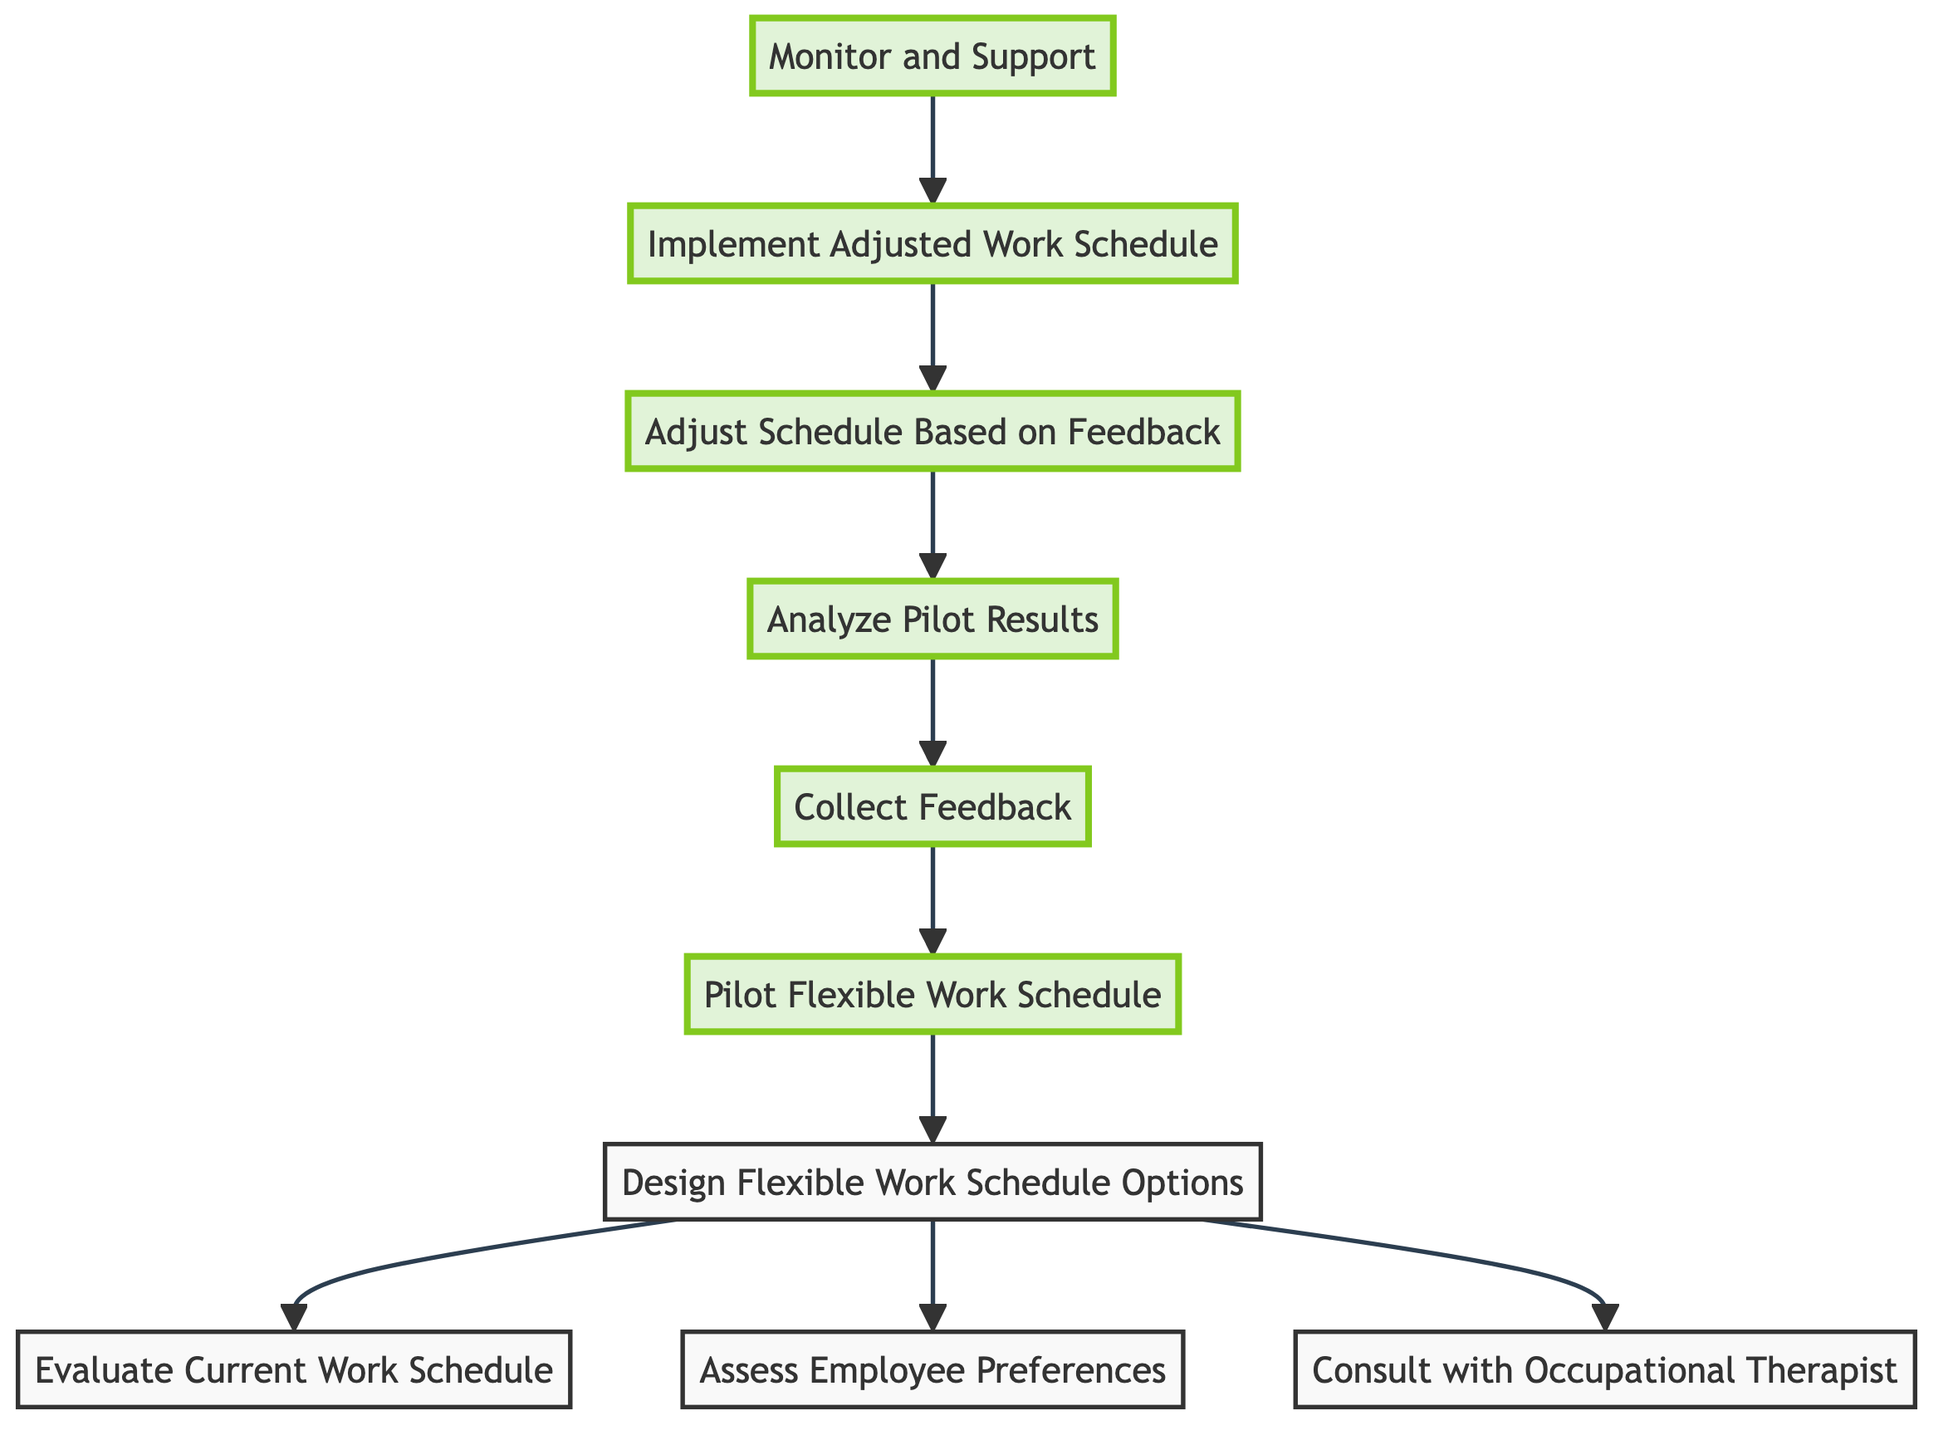What is the starting point of the process? The starting point is the first step in the flowchart, which is to evaluate the current work schedule.
Answer: Evaluate Current Work Schedule How many main steps are there in the process? By counting the distinct elements in the flowchart, there are a total of 10 main steps listed, including all nodes.
Answer: 10 What are the three requirements to design flexible work schedule options? To design options, the elements that need to be completed first are evaluating the current work schedule, assessing employee preferences, and consulting with an occupational therapist.
Answer: Evaluate Current Work Schedule, Assess Employee Preferences, Consult with Occupational Therapist Which step comes after collecting feedback? The step that follows collecting feedback is to analyze the pilot results, which evaluates the feedback and performance metrics.
Answer: Analyze Pilot Results What is the end goal of the flowchart process? The end goal of the process is to monitor and support the implemented adjusted work schedule's impact on employee satisfaction and productivity.
Answer: Monitor and Support Which elements are highlighted in the diagram? The elements that are highlighted in the diagram are the last five steps, which include implementing the adjusted work schedule, monitoring and supporting, adjusting the schedule based on feedback, analyzing pilot results, and collecting feedback.
Answer: Implement Adjusted Work Schedule, Monitor and Support, Adjust Schedule Based on Feedback, Analyze Pilot Results, Collect Feedback What is the direct action before implementing the adjusted work schedule? The direct action that must be taken before implementing the adjusted work schedule is to adjust the schedule based on feedback received from the pilot program.
Answer: Adjust Schedule Based on Feedback How does the feedback collection influence the design process? The feedback collected from the pilot influences the design process by providing necessary insights to adjust the schedule according to employee experiences and satisfaction levels.
Answer: Adjust Schedule Based on Feedback 